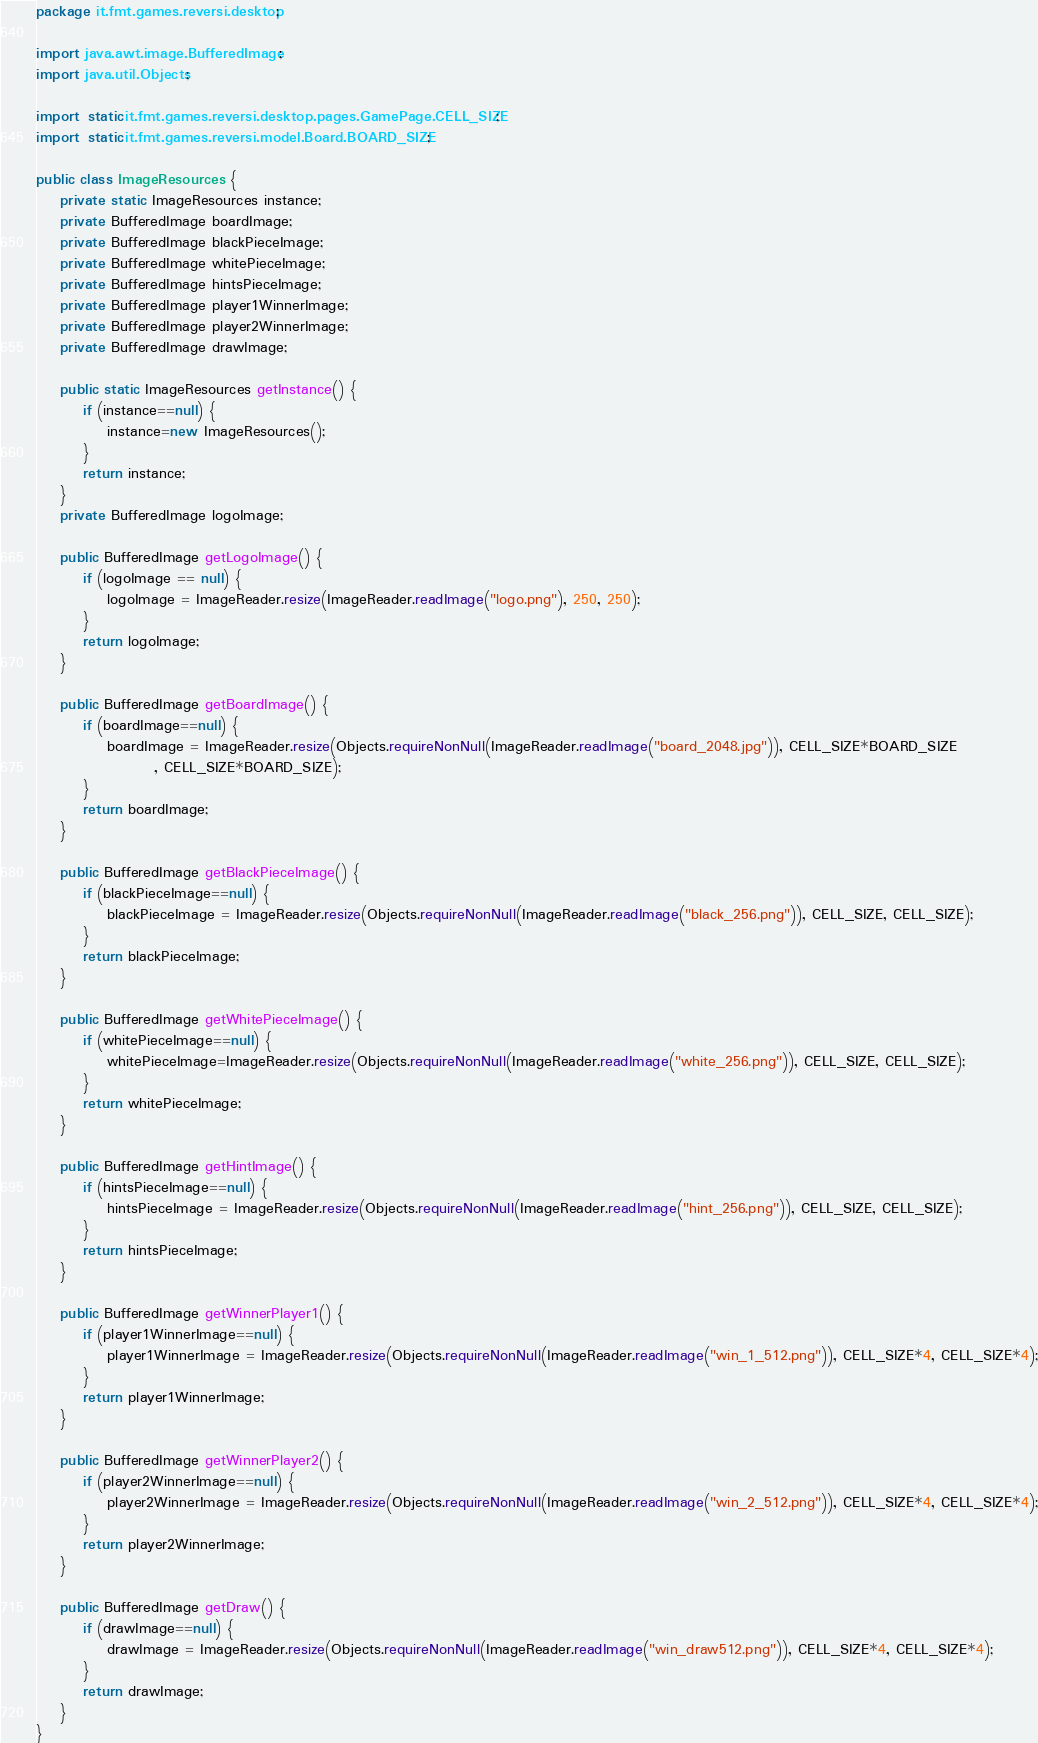Convert code to text. <code><loc_0><loc_0><loc_500><loc_500><_Java_>package it.fmt.games.reversi.desktop;

import java.awt.image.BufferedImage;
import java.util.Objects;

import static it.fmt.games.reversi.desktop.pages.GamePage.CELL_SIZE;
import static it.fmt.games.reversi.model.Board.BOARD_SIZE;

public class ImageResources {
    private static ImageResources instance;
    private BufferedImage boardImage;
    private BufferedImage blackPieceImage;
    private BufferedImage whitePieceImage;
    private BufferedImage hintsPieceImage;
    private BufferedImage player1WinnerImage;
    private BufferedImage player2WinnerImage;
    private BufferedImage drawImage;

    public static ImageResources getInstance() {
        if (instance==null) {
            instance=new ImageResources();
        }
        return instance;
    }
    private BufferedImage logoImage;

    public BufferedImage getLogoImage() {
        if (logoImage == null) {
            logoImage = ImageReader.resize(ImageReader.readImage("logo.png"), 250, 250);
        }
        return logoImage;
    }

    public BufferedImage getBoardImage() {
        if (boardImage==null) {
            boardImage = ImageReader.resize(Objects.requireNonNull(ImageReader.readImage("board_2048.jpg")), CELL_SIZE*BOARD_SIZE
                    , CELL_SIZE*BOARD_SIZE);
        }
        return boardImage;
    }

    public BufferedImage getBlackPieceImage() {
        if (blackPieceImage==null) {
            blackPieceImage = ImageReader.resize(Objects.requireNonNull(ImageReader.readImage("black_256.png")), CELL_SIZE, CELL_SIZE);
        }
        return blackPieceImage;
    }

    public BufferedImage getWhitePieceImage() {
        if (whitePieceImage==null) {
            whitePieceImage=ImageReader.resize(Objects.requireNonNull(ImageReader.readImage("white_256.png")), CELL_SIZE, CELL_SIZE);
        }
        return whitePieceImage;
    }

    public BufferedImage getHintImage() {
        if (hintsPieceImage==null) {
            hintsPieceImage = ImageReader.resize(Objects.requireNonNull(ImageReader.readImage("hint_256.png")), CELL_SIZE, CELL_SIZE);
        }
        return hintsPieceImage;
    }

    public BufferedImage getWinnerPlayer1() {
        if (player1WinnerImage==null) {
            player1WinnerImage = ImageReader.resize(Objects.requireNonNull(ImageReader.readImage("win_1_512.png")), CELL_SIZE*4, CELL_SIZE*4);
        }
        return player1WinnerImage;
    }

    public BufferedImage getWinnerPlayer2() {
        if (player2WinnerImage==null) {
            player2WinnerImage = ImageReader.resize(Objects.requireNonNull(ImageReader.readImage("win_2_512.png")), CELL_SIZE*4, CELL_SIZE*4);
        }
        return player2WinnerImage;
    }

    public BufferedImage getDraw() {
        if (drawImage==null) {
            drawImage = ImageReader.resize(Objects.requireNonNull(ImageReader.readImage("win_draw512.png")), CELL_SIZE*4, CELL_SIZE*4);
        }
        return drawImage;
    }
}
</code> 